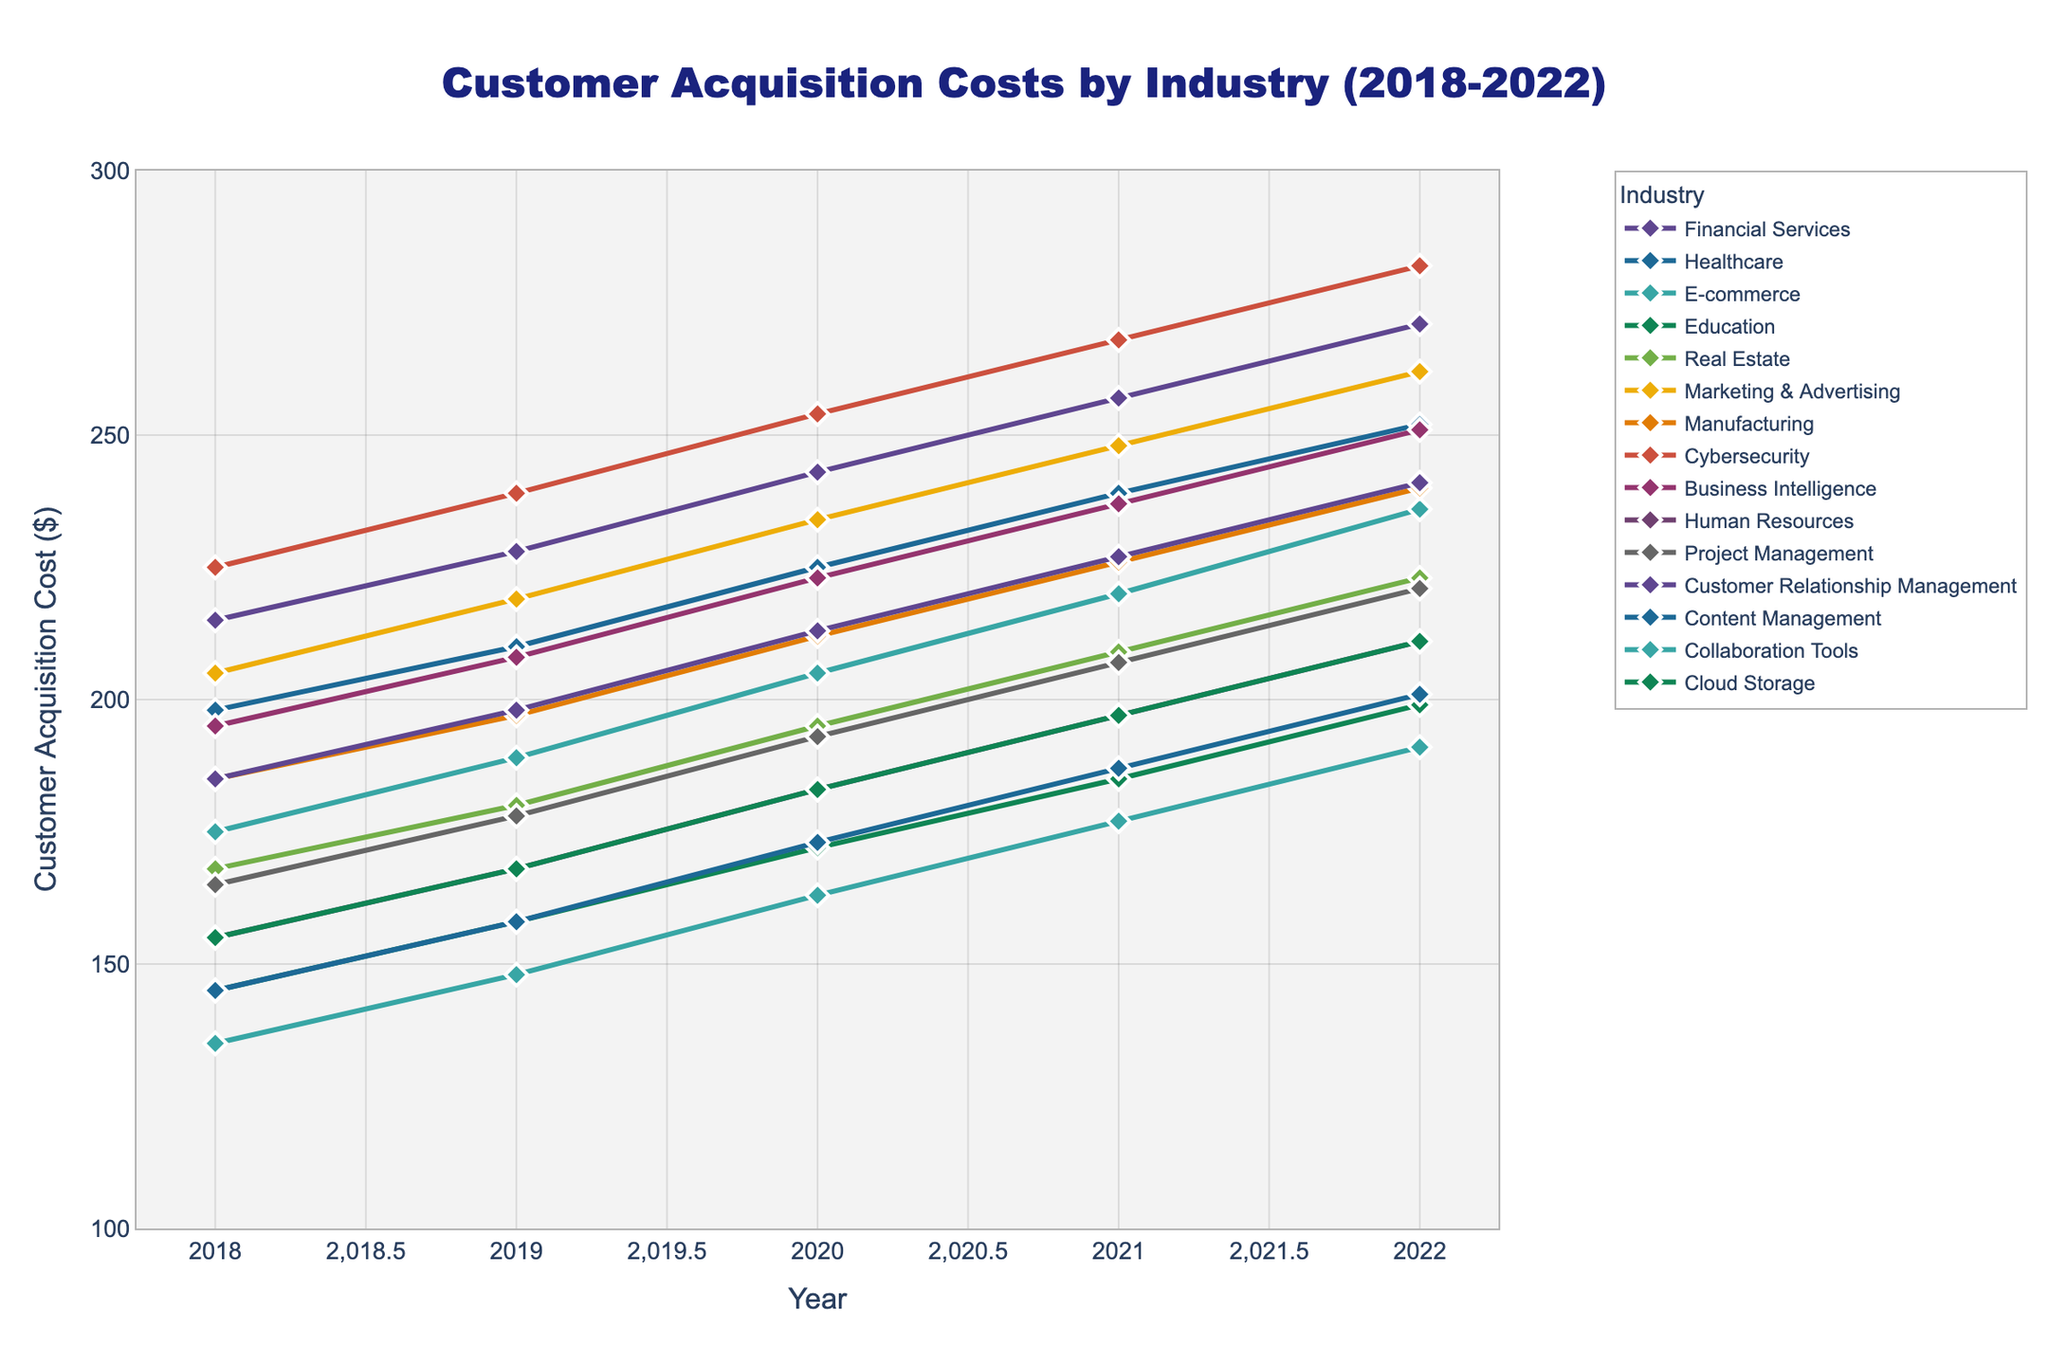What is the trend of customer acquisition cost in the Financial Services industry from 2018 to 2022? The customer acquisition cost in Financial Services increases steadily each year from 2018 to 2022. In the plot, it starts at $215 in 2018 and goes up to $271 in 2022.
Answer: Increasing trend Which industry had the highest customer acquisition cost in 2022, and what was the cost? Cybersecurity had the highest customer acquisition cost in 2022. In the plot, for the year 2022, the highest point for Cybersecurity is $282.
Answer: Cybersecurity at $282 What is the difference in customer acquisition cost between the Healthcare and Education industries in 2022? In 2022, the customer acquisition cost for Healthcare is $252 and for Education it is $199. Subtracting the Education cost from Healthcare, $252 - $199 = $53.
Answer: $53 Among the industries shown, which had the lowest customer acquisition cost in any year and what was the value? The Collaboration Tools industry had the lowest customer acquisition cost of $135 in the year 2018. This is represented by the lowest point in the plot.
Answer: Collaboration Tools at $135 How much did the customer acquisition cost for the E-commerce industry increase from 2018 to 2022? In 2018, the E-commerce industry's cost was $175, and in 2022, it was $236. The increase is $236 - $175 = $61.
Answer: $61 Which industry had a higher customer acquisition cost in 2020, Manufacturing or Real Estate, and by how much? In 2020, Manufacturing had a cost of $212 and Real Estate had $195. The difference is $212 - $195 = $17, with Manufacturing being higher.
Answer: Manufacturing by $17 What was the average customer acquisition cost for the Human Resources industry from 2018 to 2022? The costs for the Human Resources industry from 2018 to 2022 are $155, $168, $183, $197, and $211. Adding them gives 155 + 168 + 183 + 197 + 211 = 914. The average is 914 / 5 = 182.8.
Answer: $182.8 Which industries exhibited a consistent increase in customer acquisition costs from 2018 to 2022? The Financial Services, Healthcare, E-commerce, Education, Real Estate, Marketing & Advertising, Manufacturing, Cybersecurity, Business Intelligence, Human Resources, Project Management, Customer Relationship Management, Content Management, Collaboration Tools, and Cloud Storage industries all show a consistent increase in the plot from 2018 to 2022.
Answer: All industries listed What is the range of customer acquisition costs for Business Intelligence from 2018 to 2022? The range is the difference between the maximum and minimum costs for Business Intelligence from 2018 to 2022. The costs are $195 (min) and $251 (max). The range is $251 - $195 = $56.
Answer: $56 